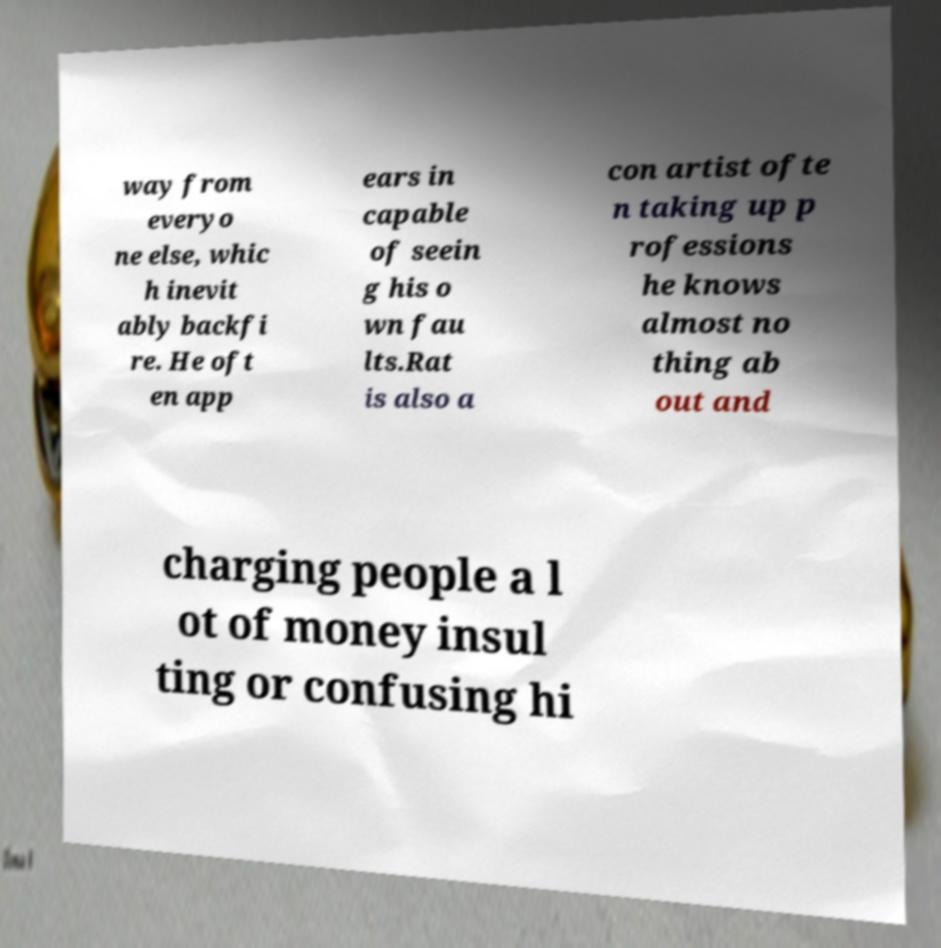Could you extract and type out the text from this image? way from everyo ne else, whic h inevit ably backfi re. He oft en app ears in capable of seein g his o wn fau lts.Rat is also a con artist ofte n taking up p rofessions he knows almost no thing ab out and charging people a l ot of money insul ting or confusing hi 